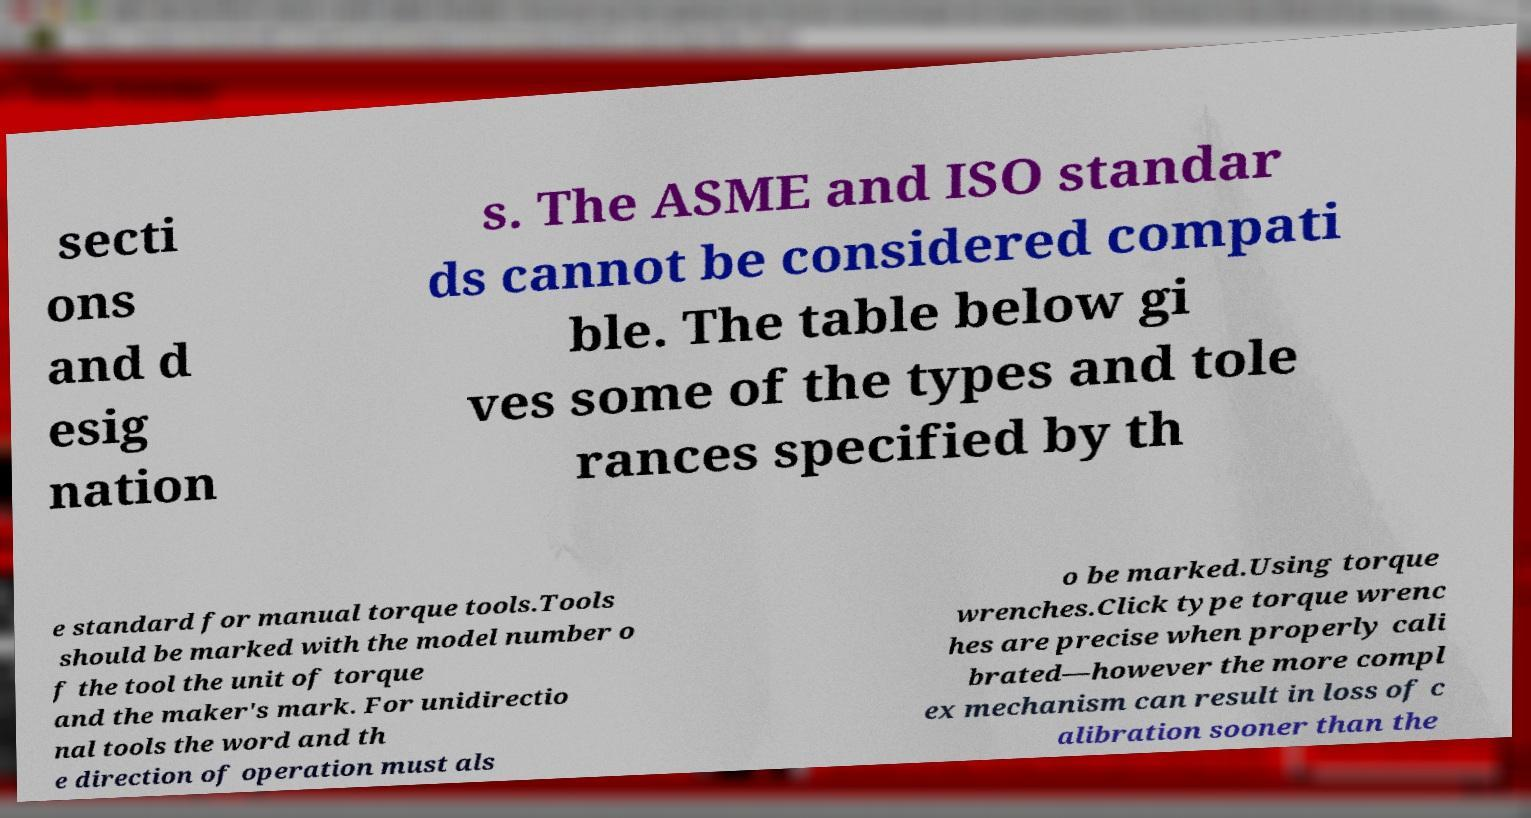Could you assist in decoding the text presented in this image and type it out clearly? secti ons and d esig nation s. The ASME and ISO standar ds cannot be considered compati ble. The table below gi ves some of the types and tole rances specified by th e standard for manual torque tools.Tools should be marked with the model number o f the tool the unit of torque and the maker's mark. For unidirectio nal tools the word and th e direction of operation must als o be marked.Using torque wrenches.Click type torque wrenc hes are precise when properly cali brated—however the more compl ex mechanism can result in loss of c alibration sooner than the 